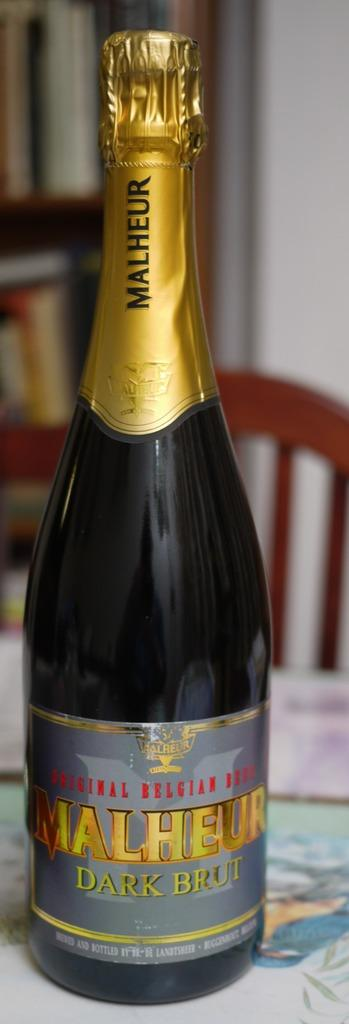<image>
Describe the image concisely. Malheur dark brut original Belgium beer sealed with foil. 